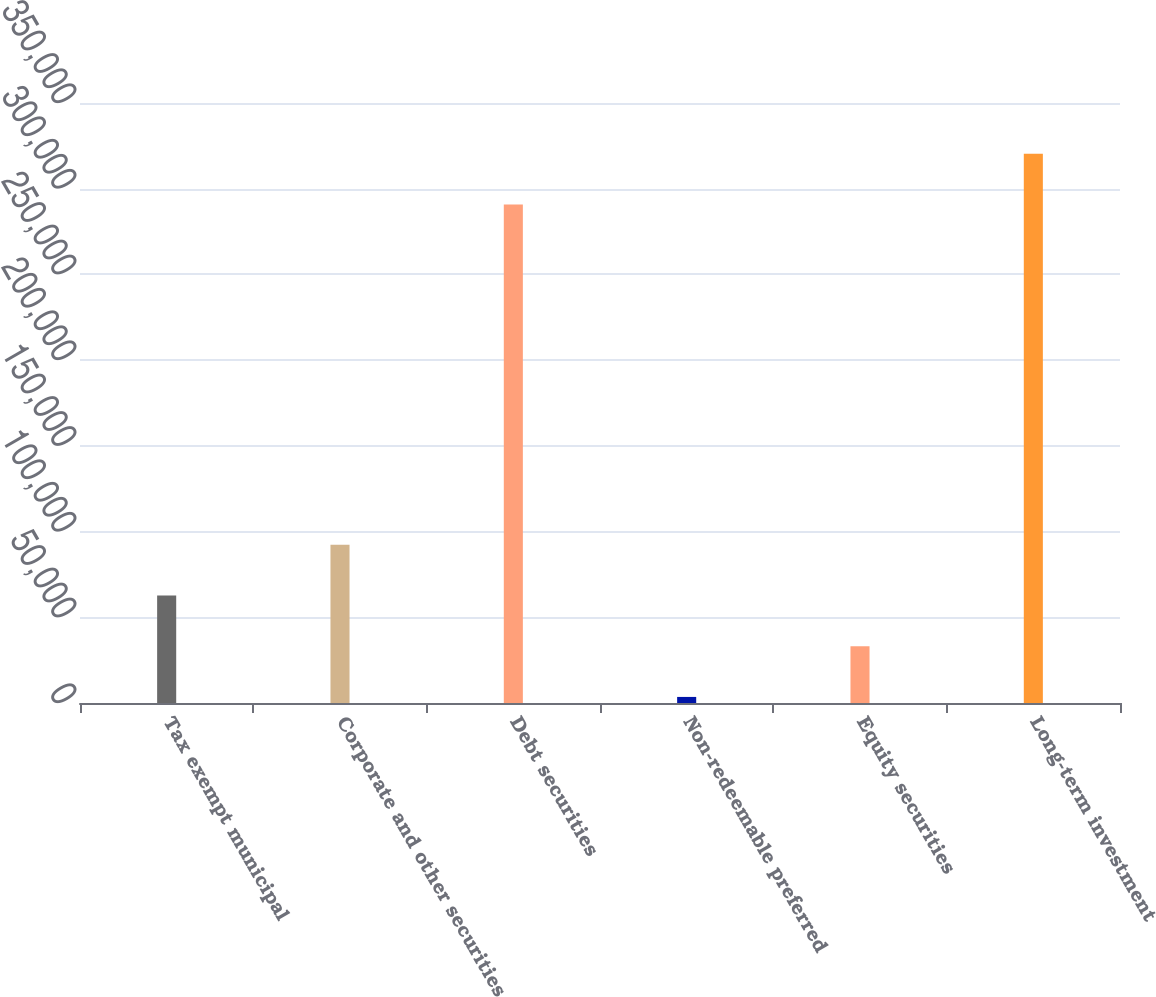Convert chart to OTSL. <chart><loc_0><loc_0><loc_500><loc_500><bar_chart><fcel>Tax exempt municipal<fcel>Corporate and other securities<fcel>Debt securities<fcel>Non-redeemable preferred<fcel>Equity securities<fcel>Long-term investment<nl><fcel>62729<fcel>92324<fcel>290862<fcel>3539<fcel>33134<fcel>320457<nl></chart> 